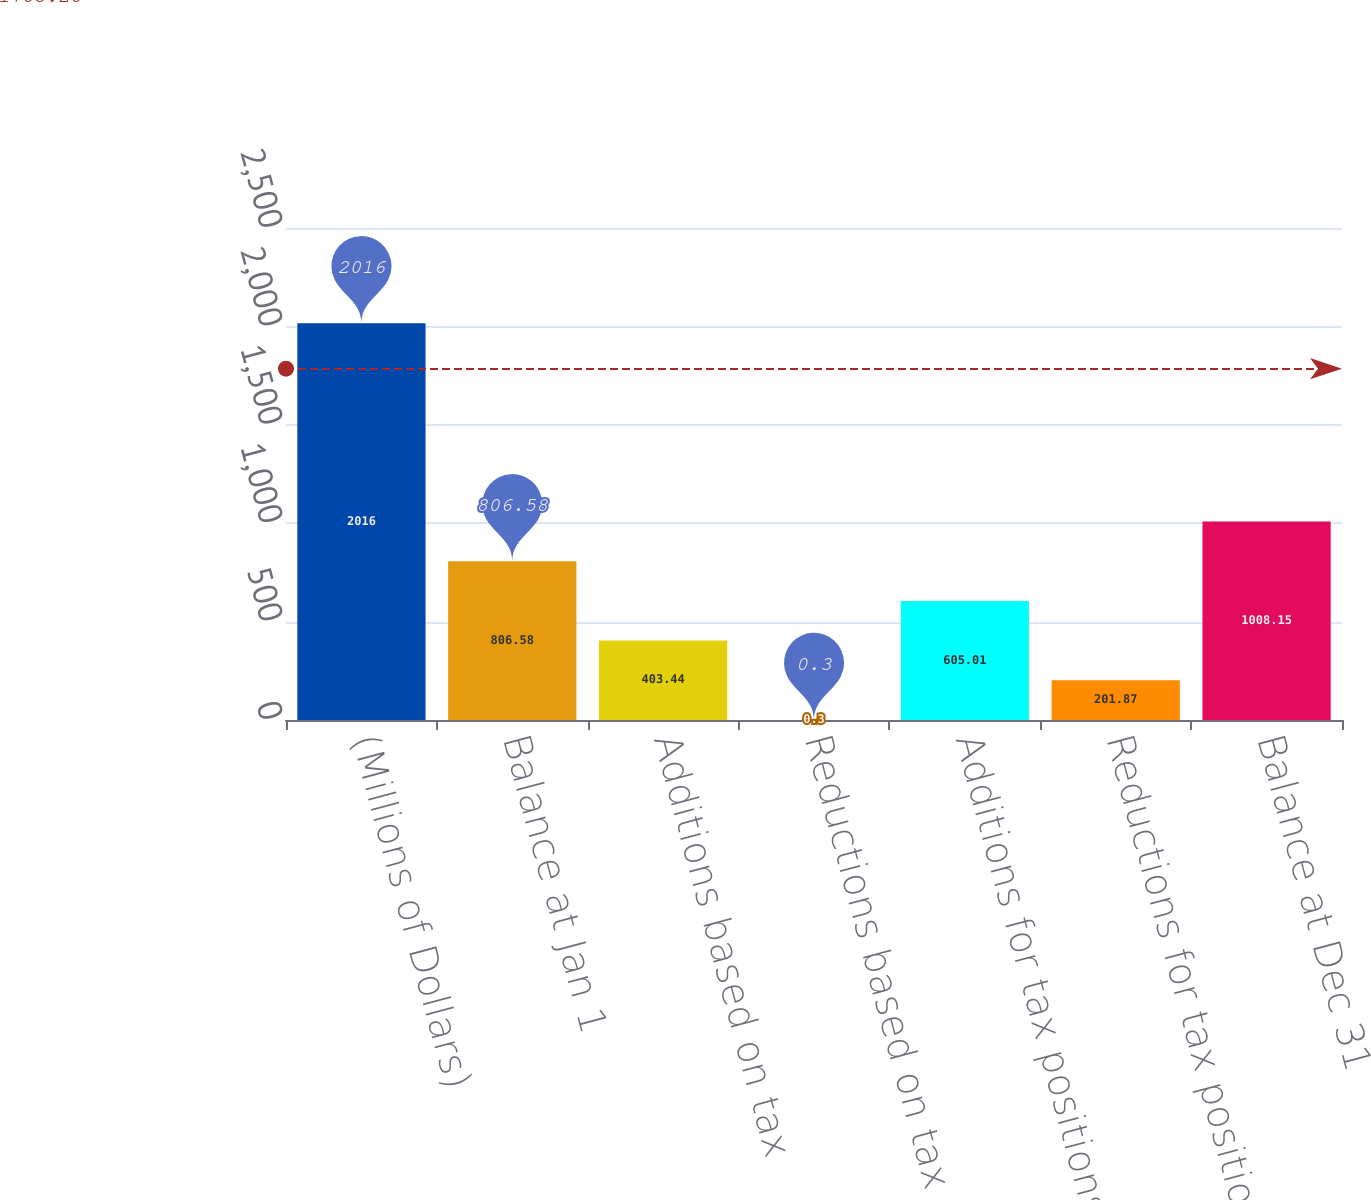Convert chart to OTSL. <chart><loc_0><loc_0><loc_500><loc_500><bar_chart><fcel>(Millions of Dollars)<fcel>Balance at Jan 1<fcel>Additions based on tax<fcel>Reductions based on tax<fcel>Additions for tax positions of<fcel>Reductions for tax positions<fcel>Balance at Dec 31<nl><fcel>2016<fcel>806.58<fcel>403.44<fcel>0.3<fcel>605.01<fcel>201.87<fcel>1008.15<nl></chart> 